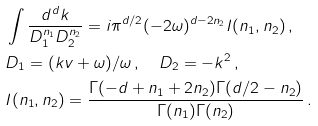<formula> <loc_0><loc_0><loc_500><loc_500>& \int \frac { d ^ { d } k } { D _ { 1 } ^ { n _ { 1 } } D _ { 2 } ^ { n _ { 2 } } } = i \pi ^ { d / 2 } ( - 2 \omega ) ^ { d - 2 n _ { 2 } } I ( n _ { 1 } , n _ { 2 } ) \, , \\ & D _ { 1 } = ( k v + \omega ) / \omega \, , \quad D _ { 2 } = - k ^ { 2 } \, , \\ & I ( n _ { 1 } , n _ { 2 } ) = \frac { \Gamma ( - d + n _ { 1 } + 2 n _ { 2 } ) \Gamma ( d / 2 - n _ { 2 } ) } { \Gamma ( n _ { 1 } ) \Gamma ( n _ { 2 } ) } \, .</formula> 